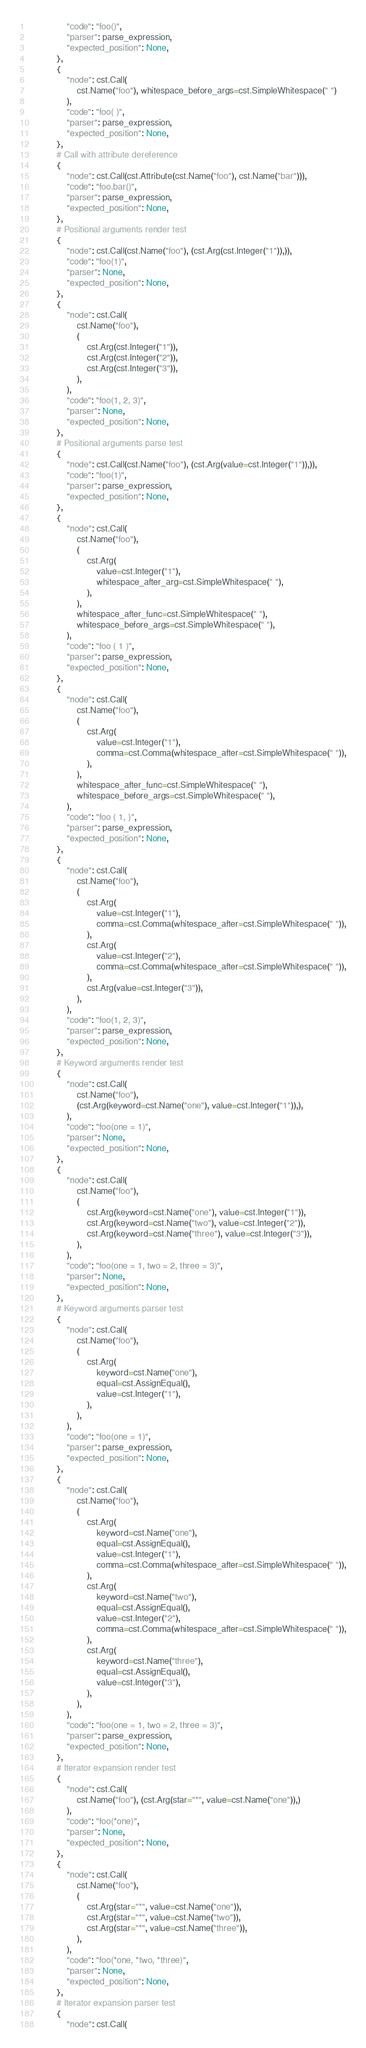Convert code to text. <code><loc_0><loc_0><loc_500><loc_500><_Python_>                "code": "foo()",
                "parser": parse_expression,
                "expected_position": None,
            },
            {
                "node": cst.Call(
                    cst.Name("foo"), whitespace_before_args=cst.SimpleWhitespace(" ")
                ),
                "code": "foo( )",
                "parser": parse_expression,
                "expected_position": None,
            },
            # Call with attribute dereference
            {
                "node": cst.Call(cst.Attribute(cst.Name("foo"), cst.Name("bar"))),
                "code": "foo.bar()",
                "parser": parse_expression,
                "expected_position": None,
            },
            # Positional arguments render test
            {
                "node": cst.Call(cst.Name("foo"), (cst.Arg(cst.Integer("1")),)),
                "code": "foo(1)",
                "parser": None,
                "expected_position": None,
            },
            {
                "node": cst.Call(
                    cst.Name("foo"),
                    (
                        cst.Arg(cst.Integer("1")),
                        cst.Arg(cst.Integer("2")),
                        cst.Arg(cst.Integer("3")),
                    ),
                ),
                "code": "foo(1, 2, 3)",
                "parser": None,
                "expected_position": None,
            },
            # Positional arguments parse test
            {
                "node": cst.Call(cst.Name("foo"), (cst.Arg(value=cst.Integer("1")),)),
                "code": "foo(1)",
                "parser": parse_expression,
                "expected_position": None,
            },
            {
                "node": cst.Call(
                    cst.Name("foo"),
                    (
                        cst.Arg(
                            value=cst.Integer("1"),
                            whitespace_after_arg=cst.SimpleWhitespace(" "),
                        ),
                    ),
                    whitespace_after_func=cst.SimpleWhitespace(" "),
                    whitespace_before_args=cst.SimpleWhitespace(" "),
                ),
                "code": "foo ( 1 )",
                "parser": parse_expression,
                "expected_position": None,
            },
            {
                "node": cst.Call(
                    cst.Name("foo"),
                    (
                        cst.Arg(
                            value=cst.Integer("1"),
                            comma=cst.Comma(whitespace_after=cst.SimpleWhitespace(" ")),
                        ),
                    ),
                    whitespace_after_func=cst.SimpleWhitespace(" "),
                    whitespace_before_args=cst.SimpleWhitespace(" "),
                ),
                "code": "foo ( 1, )",
                "parser": parse_expression,
                "expected_position": None,
            },
            {
                "node": cst.Call(
                    cst.Name("foo"),
                    (
                        cst.Arg(
                            value=cst.Integer("1"),
                            comma=cst.Comma(whitespace_after=cst.SimpleWhitespace(" ")),
                        ),
                        cst.Arg(
                            value=cst.Integer("2"),
                            comma=cst.Comma(whitespace_after=cst.SimpleWhitespace(" ")),
                        ),
                        cst.Arg(value=cst.Integer("3")),
                    ),
                ),
                "code": "foo(1, 2, 3)",
                "parser": parse_expression,
                "expected_position": None,
            },
            # Keyword arguments render test
            {
                "node": cst.Call(
                    cst.Name("foo"),
                    (cst.Arg(keyword=cst.Name("one"), value=cst.Integer("1")),),
                ),
                "code": "foo(one = 1)",
                "parser": None,
                "expected_position": None,
            },
            {
                "node": cst.Call(
                    cst.Name("foo"),
                    (
                        cst.Arg(keyword=cst.Name("one"), value=cst.Integer("1")),
                        cst.Arg(keyword=cst.Name("two"), value=cst.Integer("2")),
                        cst.Arg(keyword=cst.Name("three"), value=cst.Integer("3")),
                    ),
                ),
                "code": "foo(one = 1, two = 2, three = 3)",
                "parser": None,
                "expected_position": None,
            },
            # Keyword arguments parser test
            {
                "node": cst.Call(
                    cst.Name("foo"),
                    (
                        cst.Arg(
                            keyword=cst.Name("one"),
                            equal=cst.AssignEqual(),
                            value=cst.Integer("1"),
                        ),
                    ),
                ),
                "code": "foo(one = 1)",
                "parser": parse_expression,
                "expected_position": None,
            },
            {
                "node": cst.Call(
                    cst.Name("foo"),
                    (
                        cst.Arg(
                            keyword=cst.Name("one"),
                            equal=cst.AssignEqual(),
                            value=cst.Integer("1"),
                            comma=cst.Comma(whitespace_after=cst.SimpleWhitespace(" ")),
                        ),
                        cst.Arg(
                            keyword=cst.Name("two"),
                            equal=cst.AssignEqual(),
                            value=cst.Integer("2"),
                            comma=cst.Comma(whitespace_after=cst.SimpleWhitespace(" ")),
                        ),
                        cst.Arg(
                            keyword=cst.Name("three"),
                            equal=cst.AssignEqual(),
                            value=cst.Integer("3"),
                        ),
                    ),
                ),
                "code": "foo(one = 1, two = 2, three = 3)",
                "parser": parse_expression,
                "expected_position": None,
            },
            # Iterator expansion render test
            {
                "node": cst.Call(
                    cst.Name("foo"), (cst.Arg(star="*", value=cst.Name("one")),)
                ),
                "code": "foo(*one)",
                "parser": None,
                "expected_position": None,
            },
            {
                "node": cst.Call(
                    cst.Name("foo"),
                    (
                        cst.Arg(star="*", value=cst.Name("one")),
                        cst.Arg(star="*", value=cst.Name("two")),
                        cst.Arg(star="*", value=cst.Name("three")),
                    ),
                ),
                "code": "foo(*one, *two, *three)",
                "parser": None,
                "expected_position": None,
            },
            # Iterator expansion parser test
            {
                "node": cst.Call(</code> 